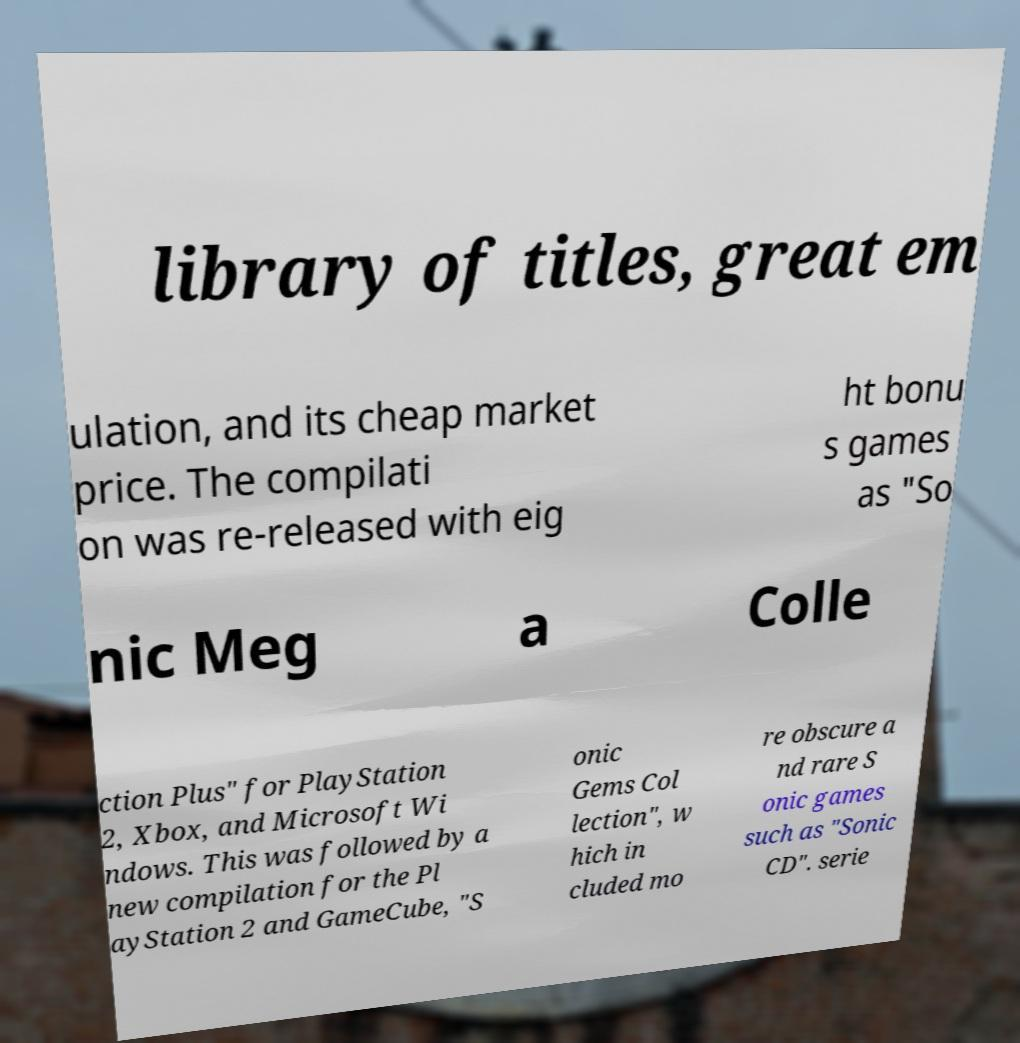I need the written content from this picture converted into text. Can you do that? library of titles, great em ulation, and its cheap market price. The compilati on was re-released with eig ht bonu s games as "So nic Meg a Colle ction Plus" for PlayStation 2, Xbox, and Microsoft Wi ndows. This was followed by a new compilation for the Pl ayStation 2 and GameCube, "S onic Gems Col lection", w hich in cluded mo re obscure a nd rare S onic games such as "Sonic CD". serie 